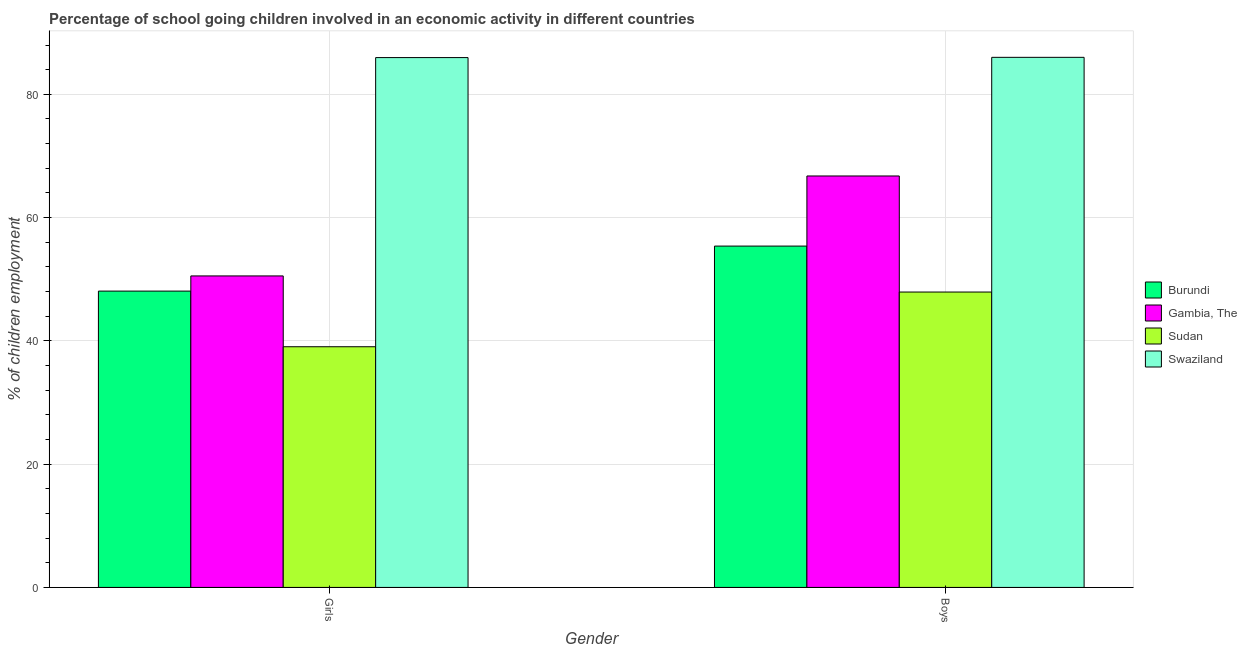Are the number of bars per tick equal to the number of legend labels?
Offer a very short reply. Yes. Are the number of bars on each tick of the X-axis equal?
Give a very brief answer. Yes. How many bars are there on the 1st tick from the left?
Your answer should be compact. 4. What is the label of the 1st group of bars from the left?
Offer a terse response. Girls. What is the percentage of school going boys in Burundi?
Provide a succinct answer. 55.38. Across all countries, what is the maximum percentage of school going boys?
Make the answer very short. 86. Across all countries, what is the minimum percentage of school going girls?
Ensure brevity in your answer.  39.05. In which country was the percentage of school going girls maximum?
Offer a terse response. Swaziland. In which country was the percentage of school going girls minimum?
Ensure brevity in your answer.  Sudan. What is the total percentage of school going girls in the graph?
Your answer should be very brief. 223.62. What is the difference between the percentage of school going boys in Swaziland and that in Gambia, The?
Give a very brief answer. 19.25. What is the difference between the percentage of school going boys in Gambia, The and the percentage of school going girls in Sudan?
Your response must be concise. 27.7. What is the average percentage of school going girls per country?
Offer a terse response. 55.9. What is the difference between the percentage of school going girls and percentage of school going boys in Gambia, The?
Keep it short and to the point. -16.21. What is the ratio of the percentage of school going girls in Sudan to that in Swaziland?
Ensure brevity in your answer.  0.45. In how many countries, is the percentage of school going girls greater than the average percentage of school going girls taken over all countries?
Offer a very short reply. 1. What does the 4th bar from the left in Boys represents?
Provide a short and direct response. Swaziland. What does the 3rd bar from the right in Girls represents?
Your answer should be very brief. Gambia, The. How many bars are there?
Offer a terse response. 8. Are all the bars in the graph horizontal?
Ensure brevity in your answer.  No. How many countries are there in the graph?
Offer a terse response. 4. What is the difference between two consecutive major ticks on the Y-axis?
Provide a short and direct response. 20. Does the graph contain any zero values?
Your answer should be compact. No. Does the graph contain grids?
Provide a short and direct response. Yes. How many legend labels are there?
Give a very brief answer. 4. What is the title of the graph?
Give a very brief answer. Percentage of school going children involved in an economic activity in different countries. Does "Uganda" appear as one of the legend labels in the graph?
Provide a short and direct response. No. What is the label or title of the X-axis?
Your answer should be very brief. Gender. What is the label or title of the Y-axis?
Your answer should be very brief. % of children employment. What is the % of children employment in Burundi in Girls?
Provide a succinct answer. 48.07. What is the % of children employment of Gambia, The in Girls?
Provide a succinct answer. 50.54. What is the % of children employment in Sudan in Girls?
Make the answer very short. 39.05. What is the % of children employment in Swaziland in Girls?
Offer a terse response. 85.96. What is the % of children employment of Burundi in Boys?
Your answer should be compact. 55.38. What is the % of children employment of Gambia, The in Boys?
Offer a terse response. 66.75. What is the % of children employment in Sudan in Boys?
Keep it short and to the point. 47.92. What is the % of children employment in Swaziland in Boys?
Offer a very short reply. 86. Across all Gender, what is the maximum % of children employment in Burundi?
Your response must be concise. 55.38. Across all Gender, what is the maximum % of children employment in Gambia, The?
Make the answer very short. 66.75. Across all Gender, what is the maximum % of children employment in Sudan?
Offer a terse response. 47.92. Across all Gender, what is the maximum % of children employment of Swaziland?
Make the answer very short. 86. Across all Gender, what is the minimum % of children employment of Burundi?
Provide a succinct answer. 48.07. Across all Gender, what is the minimum % of children employment of Gambia, The?
Ensure brevity in your answer.  50.54. Across all Gender, what is the minimum % of children employment of Sudan?
Keep it short and to the point. 39.05. Across all Gender, what is the minimum % of children employment in Swaziland?
Provide a short and direct response. 85.96. What is the total % of children employment of Burundi in the graph?
Make the answer very short. 103.45. What is the total % of children employment in Gambia, The in the graph?
Ensure brevity in your answer.  117.29. What is the total % of children employment of Sudan in the graph?
Provide a short and direct response. 86.97. What is the total % of children employment of Swaziland in the graph?
Offer a terse response. 171.96. What is the difference between the % of children employment of Burundi in Girls and that in Boys?
Offer a very short reply. -7.3. What is the difference between the % of children employment of Gambia, The in Girls and that in Boys?
Provide a short and direct response. -16.21. What is the difference between the % of children employment in Sudan in Girls and that in Boys?
Provide a succinct answer. -8.88. What is the difference between the % of children employment of Swaziland in Girls and that in Boys?
Offer a very short reply. -0.04. What is the difference between the % of children employment of Burundi in Girls and the % of children employment of Gambia, The in Boys?
Make the answer very short. -18.68. What is the difference between the % of children employment of Burundi in Girls and the % of children employment of Sudan in Boys?
Make the answer very short. 0.15. What is the difference between the % of children employment in Burundi in Girls and the % of children employment in Swaziland in Boys?
Provide a short and direct response. -37.93. What is the difference between the % of children employment of Gambia, The in Girls and the % of children employment of Sudan in Boys?
Make the answer very short. 2.61. What is the difference between the % of children employment in Gambia, The in Girls and the % of children employment in Swaziland in Boys?
Offer a terse response. -35.46. What is the difference between the % of children employment of Sudan in Girls and the % of children employment of Swaziland in Boys?
Your answer should be very brief. -46.95. What is the average % of children employment in Burundi per Gender?
Your answer should be compact. 51.73. What is the average % of children employment of Gambia, The per Gender?
Your response must be concise. 58.64. What is the average % of children employment in Sudan per Gender?
Ensure brevity in your answer.  43.48. What is the average % of children employment of Swaziland per Gender?
Give a very brief answer. 85.98. What is the difference between the % of children employment of Burundi and % of children employment of Gambia, The in Girls?
Offer a terse response. -2.46. What is the difference between the % of children employment of Burundi and % of children employment of Sudan in Girls?
Your answer should be very brief. 9.03. What is the difference between the % of children employment in Burundi and % of children employment in Swaziland in Girls?
Provide a succinct answer. -37.88. What is the difference between the % of children employment in Gambia, The and % of children employment in Sudan in Girls?
Keep it short and to the point. 11.49. What is the difference between the % of children employment in Gambia, The and % of children employment in Swaziland in Girls?
Make the answer very short. -35.42. What is the difference between the % of children employment in Sudan and % of children employment in Swaziland in Girls?
Your answer should be very brief. -46.91. What is the difference between the % of children employment of Burundi and % of children employment of Gambia, The in Boys?
Provide a succinct answer. -11.37. What is the difference between the % of children employment in Burundi and % of children employment in Sudan in Boys?
Offer a terse response. 7.46. What is the difference between the % of children employment of Burundi and % of children employment of Swaziland in Boys?
Your answer should be very brief. -30.62. What is the difference between the % of children employment in Gambia, The and % of children employment in Sudan in Boys?
Your answer should be very brief. 18.83. What is the difference between the % of children employment of Gambia, The and % of children employment of Swaziland in Boys?
Provide a short and direct response. -19.25. What is the difference between the % of children employment in Sudan and % of children employment in Swaziland in Boys?
Offer a very short reply. -38.08. What is the ratio of the % of children employment in Burundi in Girls to that in Boys?
Offer a terse response. 0.87. What is the ratio of the % of children employment of Gambia, The in Girls to that in Boys?
Ensure brevity in your answer.  0.76. What is the ratio of the % of children employment in Sudan in Girls to that in Boys?
Make the answer very short. 0.81. What is the ratio of the % of children employment of Swaziland in Girls to that in Boys?
Your answer should be compact. 1. What is the difference between the highest and the second highest % of children employment of Burundi?
Offer a very short reply. 7.3. What is the difference between the highest and the second highest % of children employment of Gambia, The?
Make the answer very short. 16.21. What is the difference between the highest and the second highest % of children employment in Sudan?
Make the answer very short. 8.88. What is the difference between the highest and the second highest % of children employment of Swaziland?
Your answer should be compact. 0.04. What is the difference between the highest and the lowest % of children employment of Burundi?
Offer a terse response. 7.3. What is the difference between the highest and the lowest % of children employment in Gambia, The?
Your answer should be compact. 16.21. What is the difference between the highest and the lowest % of children employment in Sudan?
Ensure brevity in your answer.  8.88. What is the difference between the highest and the lowest % of children employment of Swaziland?
Offer a very short reply. 0.04. 